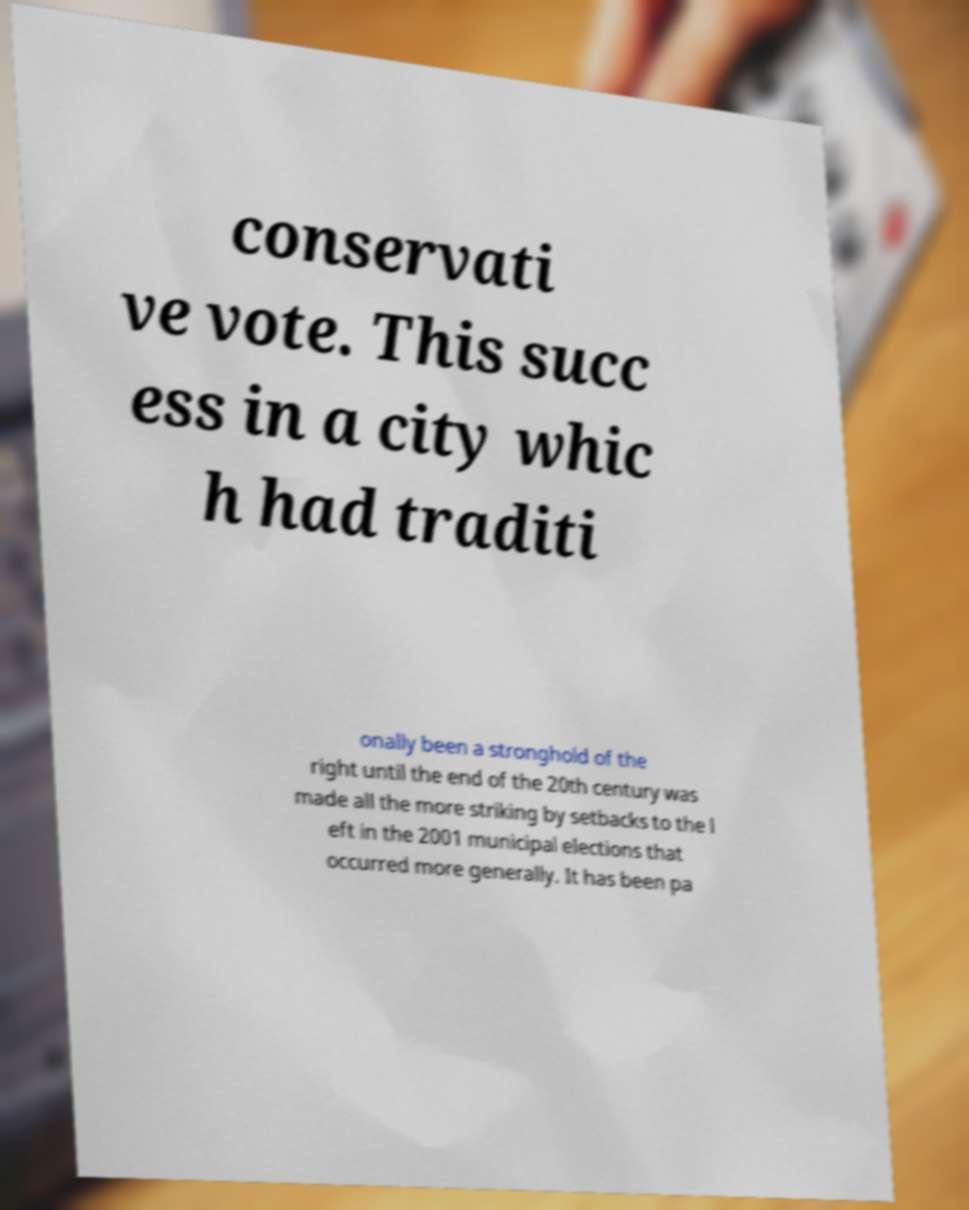Could you extract and type out the text from this image? conservati ve vote. This succ ess in a city whic h had traditi onally been a stronghold of the right until the end of the 20th century was made all the more striking by setbacks to the l eft in the 2001 municipal elections that occurred more generally. It has been pa 